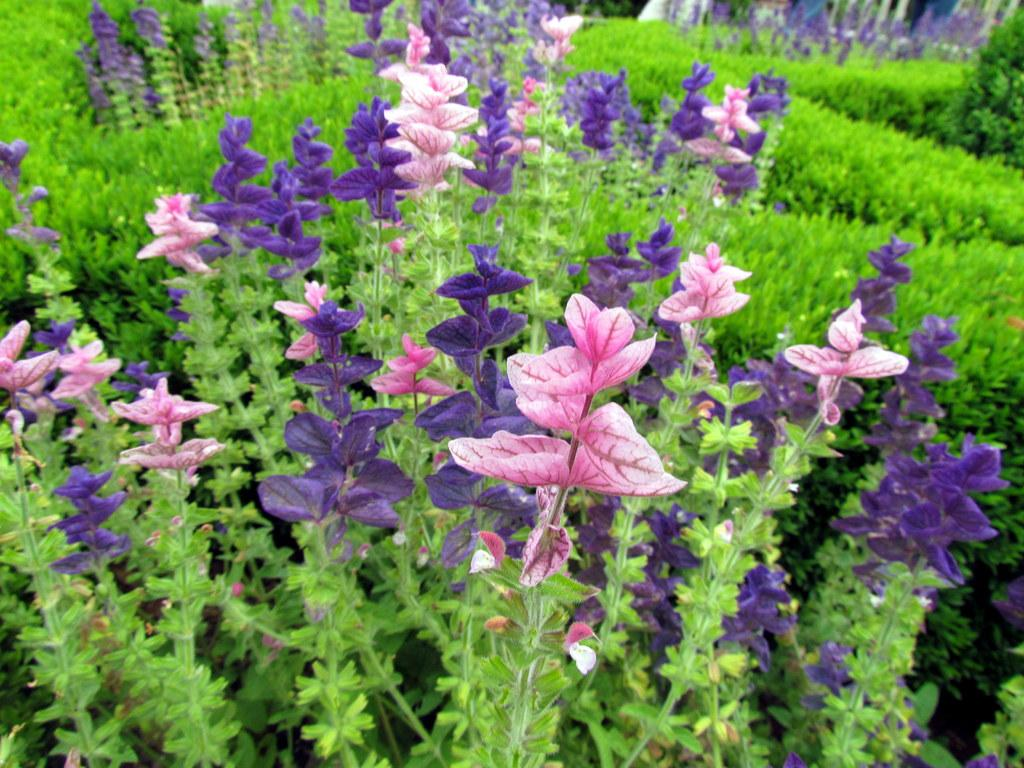What type of living organisms can be seen in the image? Flowers and plants can be seen in the image. Can you describe the flowers in the image? Unfortunately, the provided facts do not include specific details about the flowers. What is the natural setting visible in the image? The natural setting includes flowers and plants. How does the wave of chickens move across the image? There is no wave of chickens present in the image. Can you provide an example of a flower in the image? Unfortunately, the provided facts do not include specific details about the flowers, so it is not possible to provide an example. 